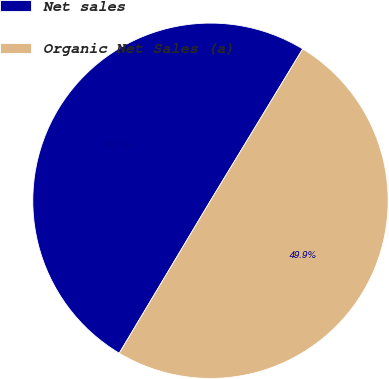Convert chart to OTSL. <chart><loc_0><loc_0><loc_500><loc_500><pie_chart><fcel>Net sales<fcel>Organic Net Sales (a)<nl><fcel>50.11%<fcel>49.89%<nl></chart> 